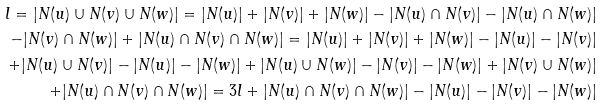<formula> <loc_0><loc_0><loc_500><loc_500>l = | N ( u ) \cup N ( v ) \cup N ( w ) | = | N ( u ) | + | N ( v ) | + | N ( w ) | - | N ( u ) \cap N ( v ) | - | N ( u ) \cap N ( w ) | \\ - | N ( v ) \cap N ( w ) | + | N ( u ) \cap N ( v ) \cap N ( w ) | = | N ( u ) | + | N ( v ) | + | N ( w ) | - | N ( u ) | - | N ( v ) | \\ + | N ( u ) \cup N ( v ) | - | N ( u ) | - | N ( w ) | + | N ( u ) \cup N ( w ) | - | N ( v ) | - | N ( w ) | + | N ( v ) \cup N ( w ) | \\ + | N ( u ) \cap N ( v ) \cap N ( w ) | = 3 l + | N ( u ) \cap N ( v ) \cap N ( w ) | - | N ( u ) | - | N ( v ) | - | N ( w ) |</formula> 